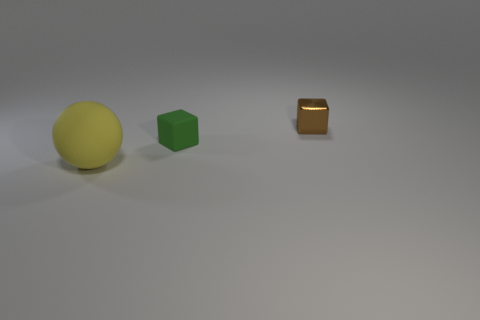The matte cube has what size?
Provide a succinct answer. Small. Is there a small cube to the left of the cube that is on the right side of the green matte object that is in front of the shiny object?
Provide a short and direct response. Yes. There is a green cube; how many cubes are in front of it?
Offer a terse response. 0. What number of objects are objects that are behind the large yellow matte object or things in front of the tiny metal thing?
Provide a succinct answer. 3. Is the number of green matte objects greater than the number of things?
Offer a very short reply. No. What is the color of the tiny block in front of the tiny shiny cube?
Your response must be concise. Green. Do the green rubber thing and the tiny brown metal object have the same shape?
Ensure brevity in your answer.  Yes. What is the color of the thing that is right of the rubber sphere and left of the small brown cube?
Make the answer very short. Green. Is the size of the block right of the tiny green object the same as the cube left of the small shiny block?
Provide a short and direct response. Yes. What number of things are matte objects behind the large yellow thing or big yellow shiny blocks?
Offer a very short reply. 1. 